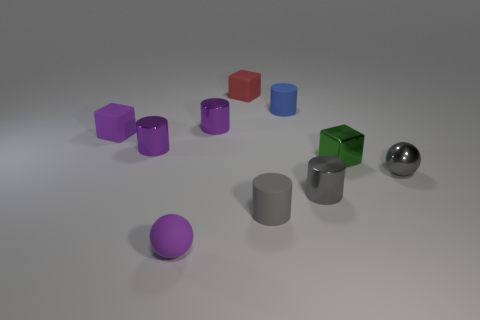Subtract all small rubber cylinders. How many cylinders are left? 3 Subtract all red cubes. How many cubes are left? 2 Subtract 3 cylinders. How many cylinders are left? 2 Add 10 tiny yellow shiny balls. How many tiny yellow shiny balls exist? 10 Subtract 0 brown blocks. How many objects are left? 10 Subtract all blocks. How many objects are left? 7 Subtract all purple spheres. Subtract all red blocks. How many spheres are left? 1 Subtract all gray cylinders. How many red blocks are left? 1 Subtract all small purple balls. Subtract all purple matte blocks. How many objects are left? 8 Add 8 small metal balls. How many small metal balls are left? 9 